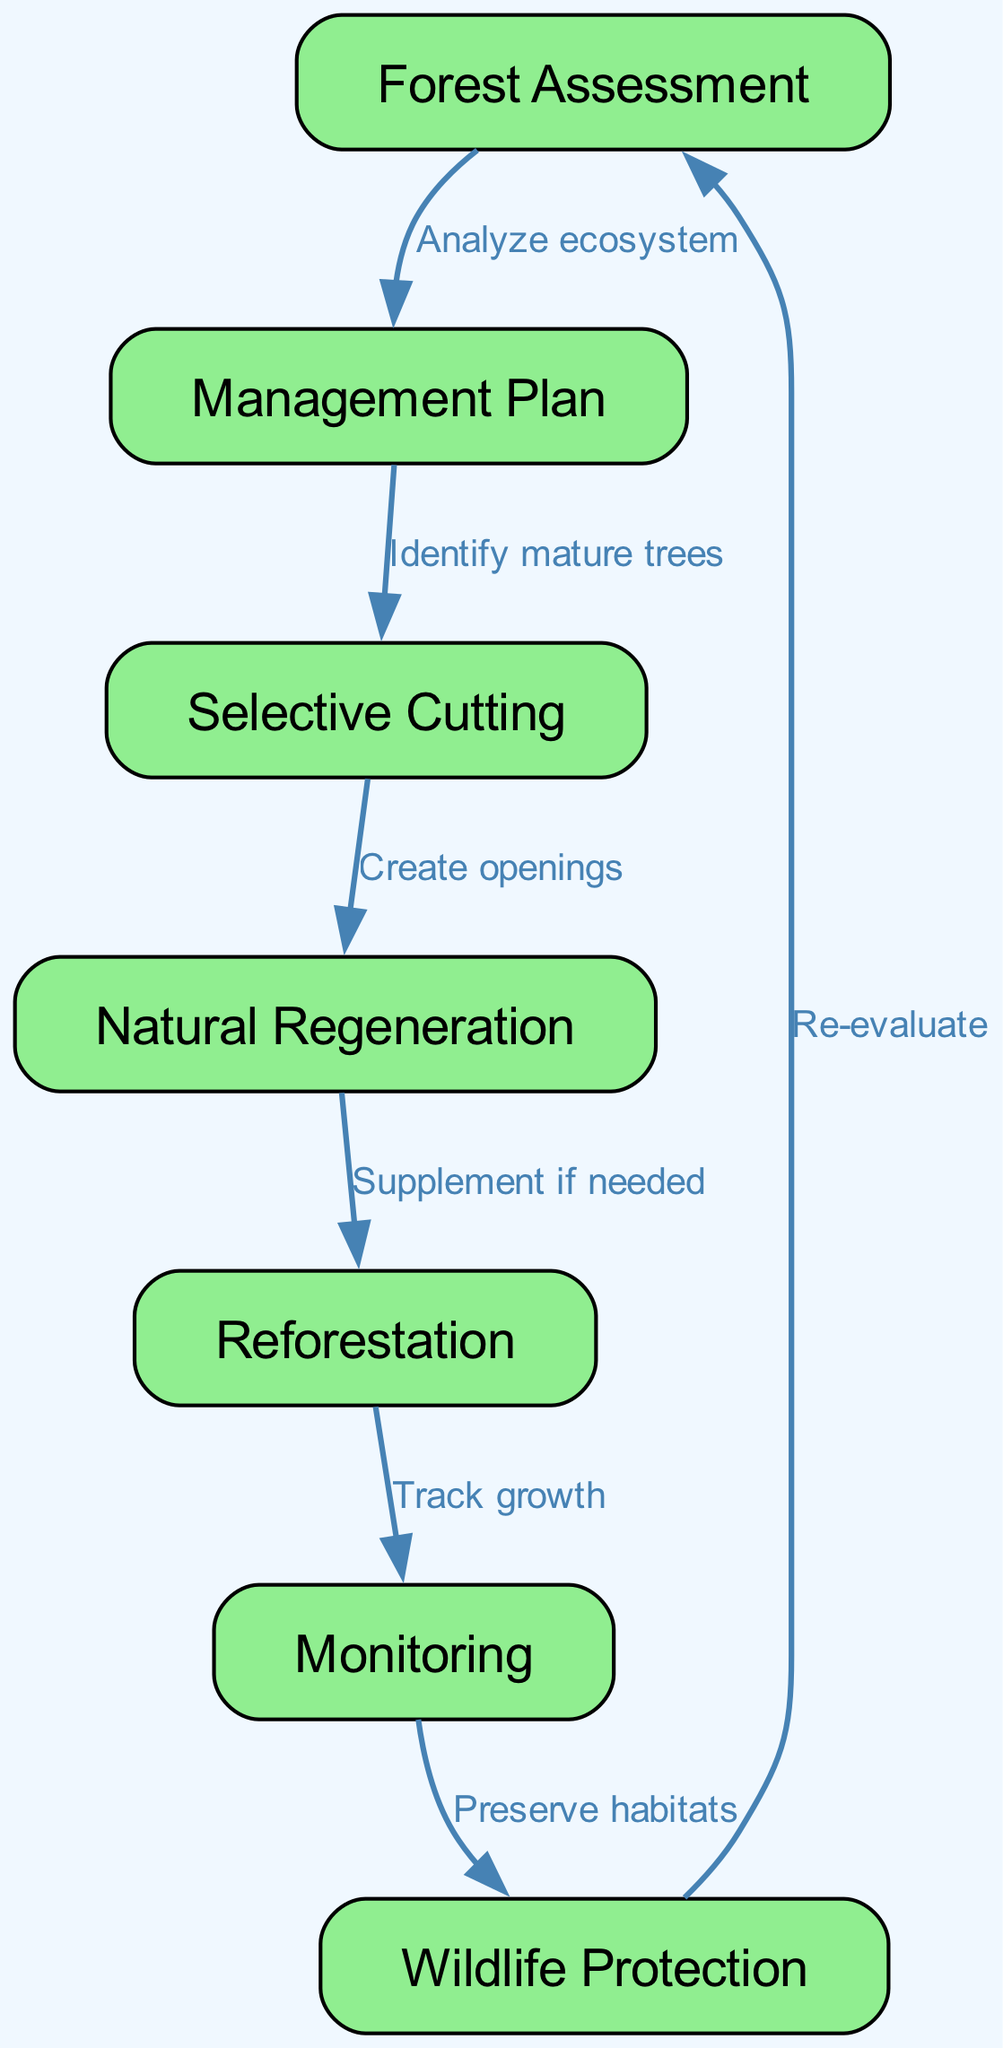What is the first step in the sustainable forest management cycle? The first step in the cycle is "Forest Assessment," where the ecosystem is analyzed to determine the condition of the forest.
Answer: Forest Assessment How many nodes are in the diagram? The diagram features a total of seven nodes, including "Forest Assessment," "Management Plan," "Selective Cutting," "Natural Regeneration," "Reforestation," "Monitoring," and "Wildlife Protection."
Answer: 7 What links "Management Plan" to "Selective Cutting"? The edge labeled "Identify mature trees" connects these two nodes, indicating that the management plan focuses on identifying trees ready for cutting.
Answer: Identify mature trees What action follows "Reforestation"? After "Reforestation," the next action is "Monitoring," which involves tracking the growth of newly planted trees to ensure their health and sustainability.
Answer: Monitoring Which two steps indicate preservation measures after timber harvesting? "Monitoring" and "Wildlife Protection" represent the steps that focus on preserving habitats and ensuring the well-being of wildlife following timber harvesting activities.
Answer: Monitoring and Wildlife Protection What is the final node in the cycle that leads back to the beginning? The final node is "Wildlife Protection," which circles back to "Forest Assessment" through re-evaluation, emphasizing the continuous nature of forest management.
Answer: Wildlife Protection What is created during the "Selective Cutting" process? The process of "Selective Cutting" is aimed at creating openings in the forest where mature trees have been removed to allow light and resources for growth in surrounding areas.
Answer: Create openings Which process involves replanting trees if natural regeneration does not suffice? The process referred to is "Reforestation," where additional trees are planted to ensure adequate forest recovery and growth.
Answer: Reforestation What is the purpose of "Monitoring" in this cycle? The purpose of "Monitoring" is to track the growth of trees after reforestation to ensure that the forest ecosystem recovers and thrives.
Answer: Track growth 